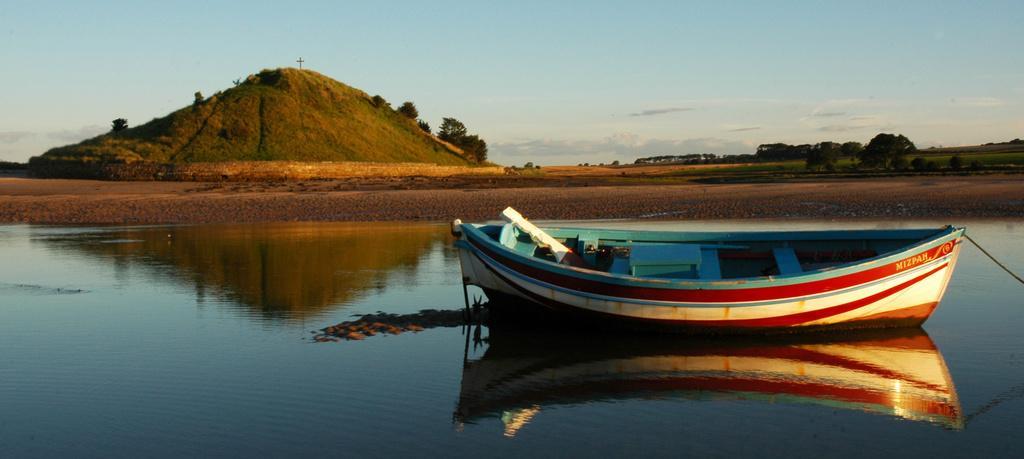How would you summarize this image in a sentence or two? In this image we can see a boat on the water. Behind the water we can see the hills and a group of trees. At the top we can see the sky. 